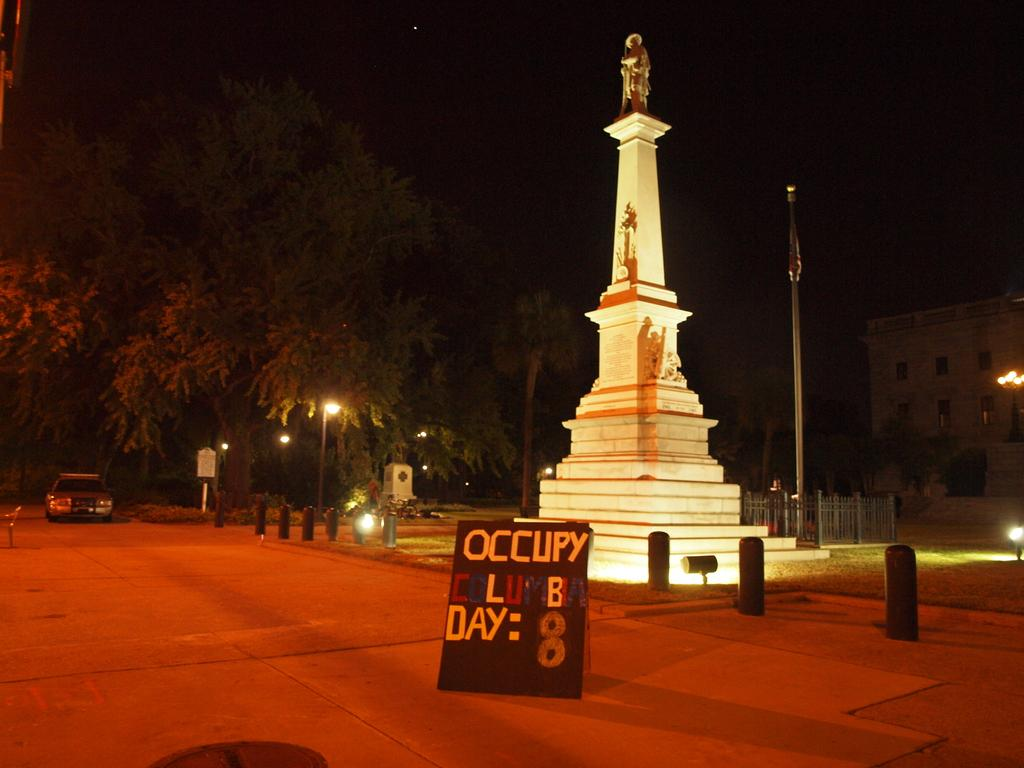<image>
Give a short and clear explanation of the subsequent image. Small building with a sign that says OCCUPY on it. 